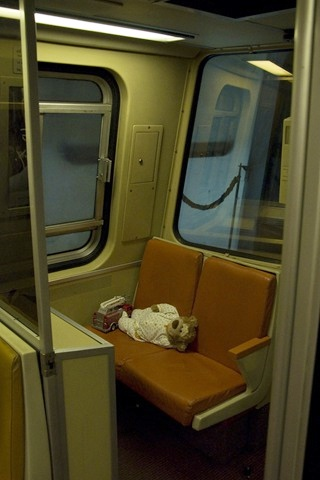Describe the objects in this image and their specific colors. I can see train in black, olive, maroon, and gray tones, chair in black, maroon, and olive tones, chair in black and olive tones, and teddy bear in black, tan, and olive tones in this image. 